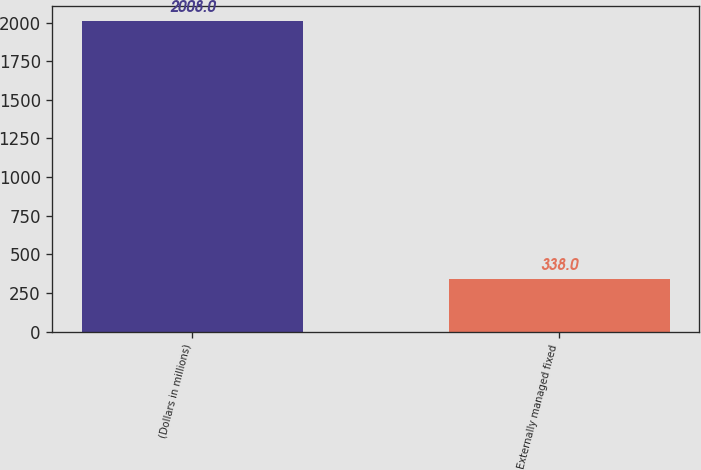Convert chart. <chart><loc_0><loc_0><loc_500><loc_500><bar_chart><fcel>(Dollars in millions)<fcel>Externally managed fixed<nl><fcel>2008<fcel>338<nl></chart> 